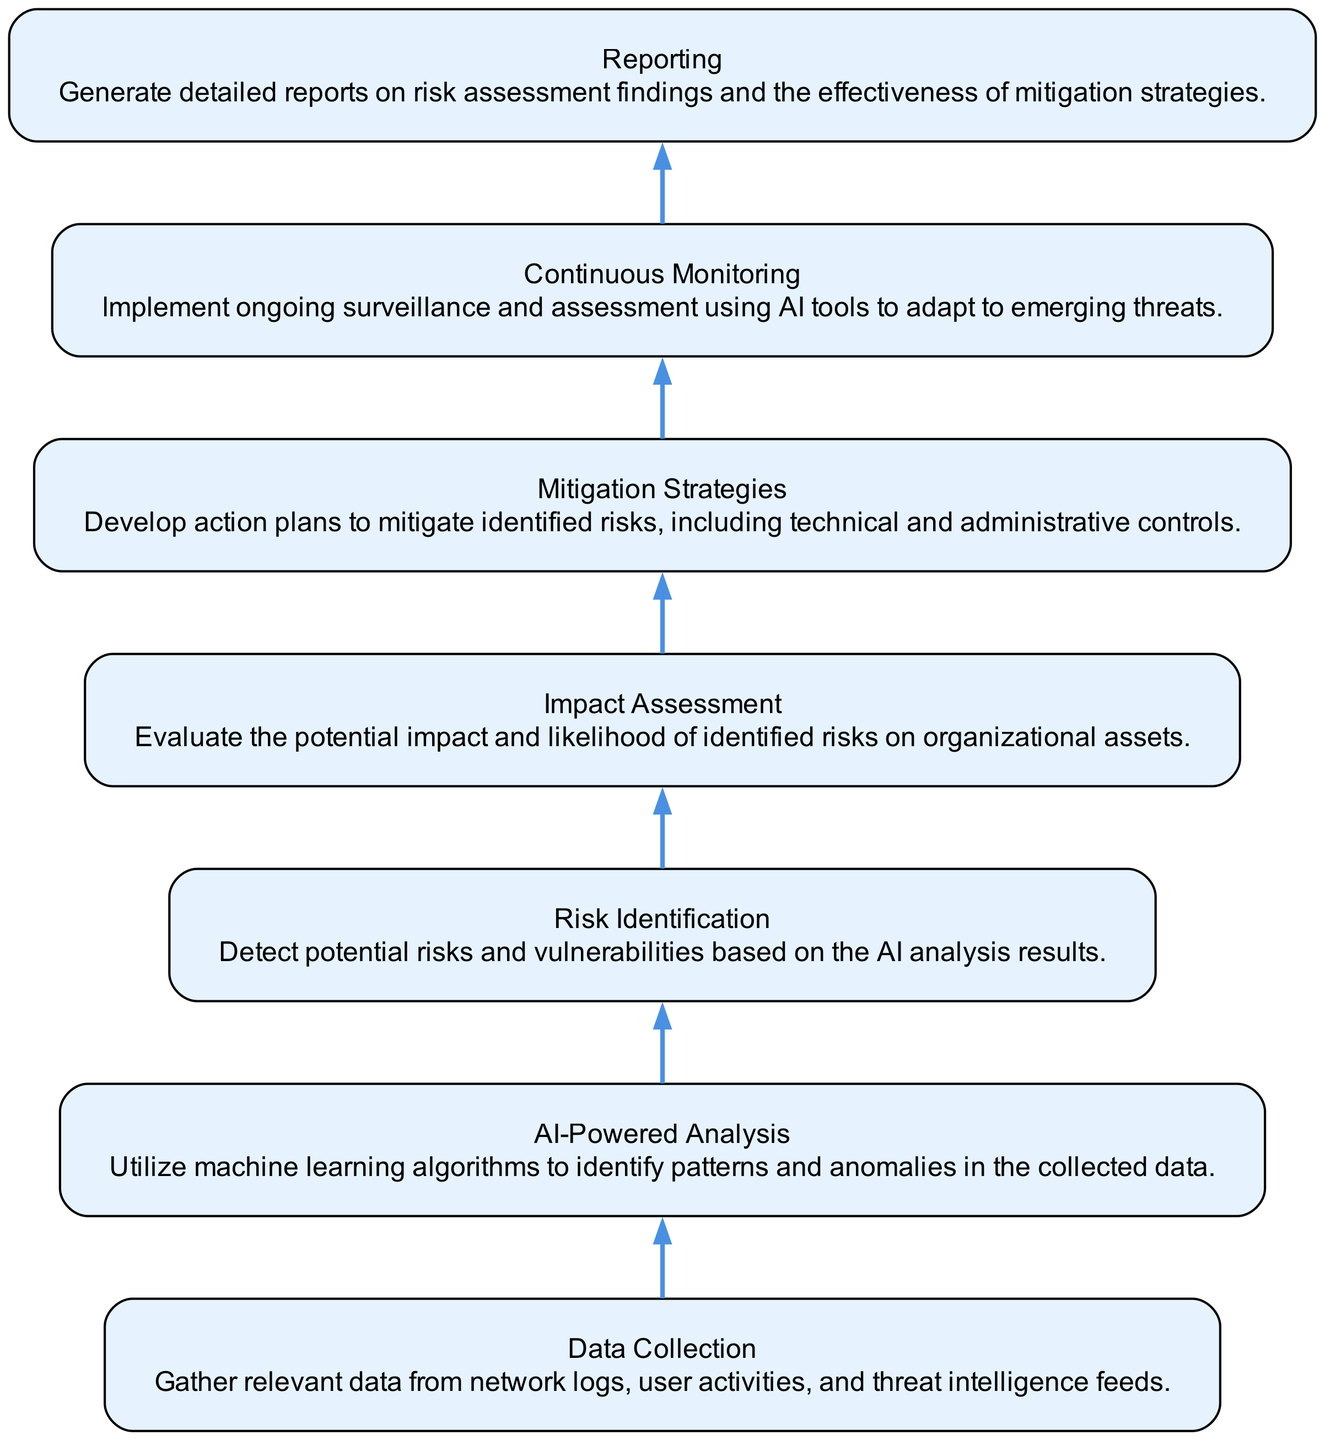What is the first step in the methodology? The first step is "Data Collection," which is the beginning of the flow. This node is positioned at the bottom of the flow chart, with all subsequent steps leading upward from it.
Answer: Data Collection How many elements are in the flow chart? By counting the individual nodes listed, there are a total of 7 different elements present in the flow chart, each representing a step in the methodology.
Answer: 7 What is the last step in the risk assessment methodology? The last step is "Reporting," which concludes the flow after all preceding steps have taken place. This node appears at the top of the flow chart.
Answer: Reporting Which step comes after "Risk Identification"? The step following "Risk Identification" is "Impact Assessment." This can be identified by the directed flow of edges that connect the two nodes in sequence.
Answer: Impact Assessment What is used to identify patterns in collected data? The method used to identify patterns is "AI-Powered Analysis," which applies machine learning algorithms. This node specifically mentions the utilization of AI tools for analysis.
Answer: AI-Powered Analysis What aspect of risks is evaluated in "Impact Assessment"? In "Impact Assessment," both the potential impact and likelihood of identified risks are evaluated, which indicates a thorough examination of how risks could affect the organization.
Answer: Potential impact and likelihood Which two elements are directly connected by an edge? All nodes in this flow chart are directly connected in a linear fashion. The edge connects "Continuous Monitoring" with "Reporting," illustrating the final action after monitoring is completed.
Answer: Continuous Monitoring and Reporting 